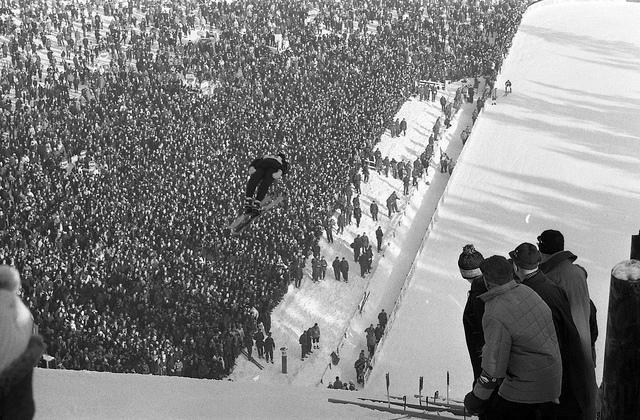Is this a color picture?
Concise answer only. No. What are the spectators watching?
Quick response, please. Skiing. Is there snow on the ground?
Give a very brief answer. Yes. 